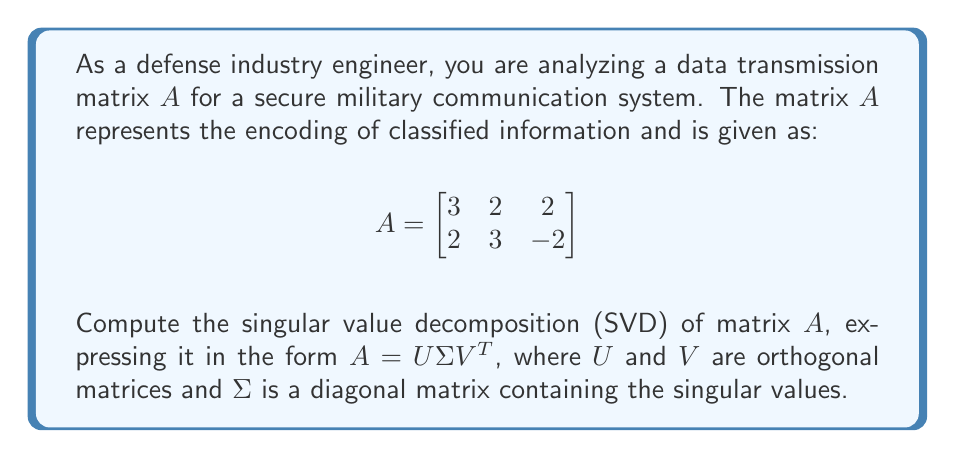Can you answer this question? To find the singular value decomposition of matrix $A$, we'll follow these steps:

1) First, calculate $A^TA$ and $AA^T$:

   $A^TA = \begin{bmatrix}
   3 & 2 \\
   2 & 3 \\
   2 & -2
   \end{bmatrix} \begin{bmatrix}
   3 & 2 & 2 \\
   2 & 3 & -2
   \end{bmatrix} = \begin{bmatrix}
   17 & 12 & 2 \\
   12 & 13 & -2 \\
   2 & -2 & 8
   \end{bmatrix}$

   $AA^T = \begin{bmatrix}
   3 & 2 & 2 \\
   2 & 3 & -2
   \end{bmatrix} \begin{bmatrix}
   3 & 2 \\
   2 & 3 \\
   2 & -2
   \end{bmatrix} = \begin{bmatrix}
   17 & 12 \\
   12 & 17
   \end{bmatrix}$

2) Find the eigenvalues of $AA^T$:
   $\det(AA^T - \lambda I) = \begin{vmatrix}
   17-\lambda & 12 \\
   12 & 17-\lambda
   \end{vmatrix} = (17-\lambda)^2 - 144 = \lambda^2 - 34\lambda + 145 = 0$

   Solving this quadratic equation: $\lambda_1 = 29, \lambda_2 = 5$

3) The singular values are the square roots of these eigenvalues:
   $\sigma_1 = \sqrt{29}, \sigma_2 = \sqrt{5}$

4) Find the eigenvectors of $AA^T$ to form $U$:
   For $\lambda_1 = 29$: $(AA^T - 29I)x = 0$ gives $x = (1, 1)^T$
   For $\lambda_2 = 5$: $(AA^T - 5I)x = 0$ gives $x = (-1, 1)^T$

   Normalizing these vectors:
   $u_1 = \frac{1}{\sqrt{2}}(1, 1)^T, u_2 = \frac{1}{\sqrt{2}}(-1, 1)^T$

   $U = \begin{bmatrix}
   \frac{1}{\sqrt{2}} & -\frac{1}{\sqrt{2}} \\
   \frac{1}{\sqrt{2}} & \frac{1}{\sqrt{2}}
   \end{bmatrix}$

5) Find the right singular vectors to form $V$:
   $v_1 = \frac{1}{\sigma_1}A^Tu_1, v_2 = \frac{1}{\sigma_2}A^Tu_2$

   $v_1 = \frac{1}{\sqrt{58}}(5, 5, 0)^T, v_2 = \frac{1}{\sqrt{10}}(0, 0, \sqrt{10})^T$

   The third right singular vector $v_3$ is orthogonal to $v_1$ and $v_2$:
   $v_3 = \frac{1}{\sqrt{58}}(-5, 5, 0)^T$

   $V = \begin{bmatrix}
   \frac{5}{\sqrt{58}} & 0 & -\frac{5}{\sqrt{58}} \\
   \frac{5}{\sqrt{58}} & 0 & \frac{5}{\sqrt{58}} \\
   0 & 1 & 0
   \end{bmatrix}$

6) Form the diagonal matrix $\Sigma$:
   $\Sigma = \begin{bmatrix}
   \sqrt{29} & 0 \\
   0 & \sqrt{5} \\
   0 & 0
   \end{bmatrix}$

Thus, we have computed the SVD of matrix $A$ as $A = U\Sigma V^T$.
Answer: $A = U\Sigma V^T$, where:

$U = \begin{bmatrix}
\frac{1}{\sqrt{2}} & -\frac{1}{\sqrt{2}} \\
\frac{1}{\sqrt{2}} & \frac{1}{\sqrt{2}}
\end{bmatrix}$

$\Sigma = \begin{bmatrix}
\sqrt{29} & 0 \\
0 & \sqrt{5} \\
0 & 0
\end{bmatrix}$

$V = \begin{bmatrix}
\frac{5}{\sqrt{58}} & 0 & -\frac{5}{\sqrt{58}} \\
\frac{5}{\sqrt{58}} & 0 & \frac{5}{\sqrt{58}} \\
0 & 1 & 0
\end{bmatrix}$ 